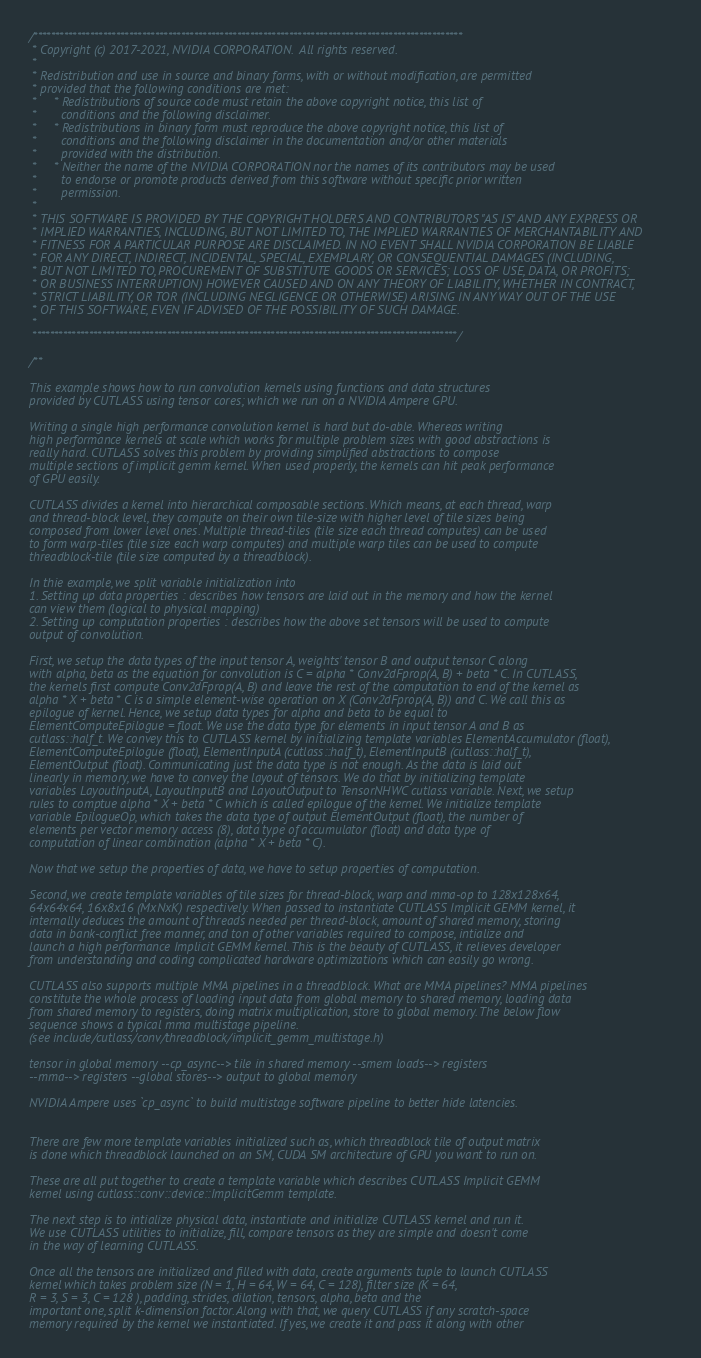Convert code to text. <code><loc_0><loc_0><loc_500><loc_500><_Cuda_>/***************************************************************************************************
 * Copyright (c) 2017-2021, NVIDIA CORPORATION.  All rights reserved.
 *
 * Redistribution and use in source and binary forms, with or without modification, are permitted
 * provided that the following conditions are met:
 *     * Redistributions of source code must retain the above copyright notice, this list of
 *       conditions and the following disclaimer.
 *     * Redistributions in binary form must reproduce the above copyright notice, this list of
 *       conditions and the following disclaimer in the documentation and/or other materials
 *       provided with the distribution.
 *     * Neither the name of the NVIDIA CORPORATION nor the names of its contributors may be used
 *       to endorse or promote products derived from this software without specific prior written
 *       permission.
 *
 * THIS SOFTWARE IS PROVIDED BY THE COPYRIGHT HOLDERS AND CONTRIBUTORS "AS IS" AND ANY EXPRESS OR
 * IMPLIED WARRANTIES, INCLUDING, BUT NOT LIMITED TO, THE IMPLIED WARRANTIES OF MERCHANTABILITY AND
 * FITNESS FOR A PARTICULAR PURPOSE ARE DISCLAIMED. IN NO EVENT SHALL NVIDIA CORPORATION BE LIABLE
 * FOR ANY DIRECT, INDIRECT, INCIDENTAL, SPECIAL, EXEMPLARY, OR CONSEQUENTIAL DAMAGES (INCLUDING,
 * BUT NOT LIMITED TO, PROCUREMENT OF SUBSTITUTE GOODS OR SERVICES; LOSS OF USE, DATA, OR PROFITS;
 * OR BUSINESS INTERRUPTION) HOWEVER CAUSED AND ON ANY THEORY OF LIABILITY, WHETHER IN CONTRACT,
 * STRICT LIABILITY, OR TOR (INCLUDING NEGLIGENCE OR OTHERWISE) ARISING IN ANY WAY OUT OF THE USE
 * OF THIS SOFTWARE, EVEN IF ADVISED OF THE POSSIBILITY OF SUCH DAMAGE.
 *
 **************************************************************************************************/

/**

This example shows how to run convolution kernels using functions and data structures
provided by CUTLASS using tensor cores; which we run on a NVIDIA Ampere GPU.

Writing a single high performance convolution kernel is hard but do-able. Whereas writing
high performance kernels at scale which works for multiple problem sizes with good abstractions is
really hard. CUTLASS solves this problem by providing simplified abstractions to compose
multiple sections of implicit gemm kernel. When used properly, the kernels can hit peak performance
of GPU easily.

CUTLASS divides a kernel into hierarchical composable sections. Which means, at each thread, warp
and thread-block level, they compute on their own tile-size with higher level of tile sizes being
composed from lower level ones. Multiple thread-tiles (tile size each thread computes) can be used
to form warp-tiles (tile size each warp computes) and multiple warp tiles can be used to compute
threadblock-tile (tile size computed by a threadblock).

In thie example, we split variable initialization into
1. Setting up data properties : describes how tensors are laid out in the memory and how the kernel
can view them (logical to physical mapping)
2. Setting up computation properties : describes how the above set tensors will be used to compute
output of convolution.

First, we setup the data types of the input tensor A, weights' tensor B and output tensor C along
with alpha, beta as the equation for convolution is C = alpha * Conv2dFprop(A, B) + beta * C. In CUTLASS,
the kernels first compute Conv2dFprop(A, B) and leave the rest of the computation to end of the kernel as
alpha * X + beta * C is a simple element-wise operation on X (Conv2dFprop(A, B)) and C. We call this as 
epilogue of kernel. Hence, we setup data types for alpha and beta to be equal to 
ElementComputeEpilogue = float. We use the data type for elements in input tensor A and B as 
cutlass::half_t. We convey this to CUTLASS kernel by initializing template variables ElementAccumulator (float),
ElementComputeEpilogue (float), ElementInputA (cutlass::half_t), ElementInputB (cutlass::half_t),
ElementOutput (float). Communicating just the data type is not enough. As the data is laid out 
linearly in memory, we have to convey the layout of tensors. We do that by initializing template
variables LayoutInputA, LayoutInputB and LayoutOutput to TensorNHWC cutlass variable. Next, we setup
rules to comptue alpha * X + beta * C which is called epilogue of the kernel. We initialize template
variable EpilogueOp, which takes the data type of output ElementOutput (float), the number of
elements per vector memory access (8), data type of accumulator (float) and data type of
computation of linear combination (alpha * X + beta * C).

Now that we setup the properties of data, we have to setup properties of computation.

Second, we create template variables of tile sizes for thread-block, warp and mma-op to 128x128x64,
64x64x64, 16x8x16 (MxNxK) respectively. When passed to instantiate CUTLASS Implicit GEMM kernel, it
internally deduces the amount of threads needed per thread-block, amount of shared memory, storing
data in bank-conflict free manner, and ton of other variables required to compose, intialize and
launch a high performance Implicit GEMM kernel. This is the beauty of CUTLASS, it relieves developer
from understanding and coding complicated hardware optimizations which can easily go wrong.

CUTLASS also supports multiple MMA pipelines in a threadblock. What are MMA pipelines? MMA pipelines
constitute the whole process of loading input data from global memory to shared memory, loading data
from shared memory to registers, doing matrix multiplication, store to global memory. The below flow
sequence shows a typical mma multistage pipeline.
(see include/cutlass/conv/threadblock/implicit_gemm_multistage.h)

tensor in global memory --cp_async--> tile in shared memory --smem loads--> registers 
--mma--> registers --global stores--> output to global memory

NVIDIA Ampere uses `cp_async` to build multistage software pipeline to better hide latencies.


There are few more template variables initialized such as, which threadblock tile of output matrix
is done which threadblock launched on an SM, CUDA SM architecture of GPU you want to run on.

These are all put together to create a template variable which describes CUTLASS Implicit GEMM
kernel using cutlass::conv::device::ImplicitGemm template.

The next step is to intialize physical data, instantiate and initialize CUTLASS kernel and run it.
We use CUTLASS utilities to initialize, fill, compare tensors as they are simple and doesn't come
in the way of learning CUTLASS.

Once all the tensors are initialized and filled with data, create arguments tuple to launch CUTLASS
kernel which takes problem size (N = 1, H = 64, W = 64, C = 128), filter size (K = 64,
R = 3, S = 3, C = 128 ), padding, strides, dilation, tensors, alpha, beta and the
important one, split k-dimension factor. Along with that, we query CUTLASS if any scratch-space
memory required by the kernel we instantiated. If yes, we create it and pass it along with other</code> 